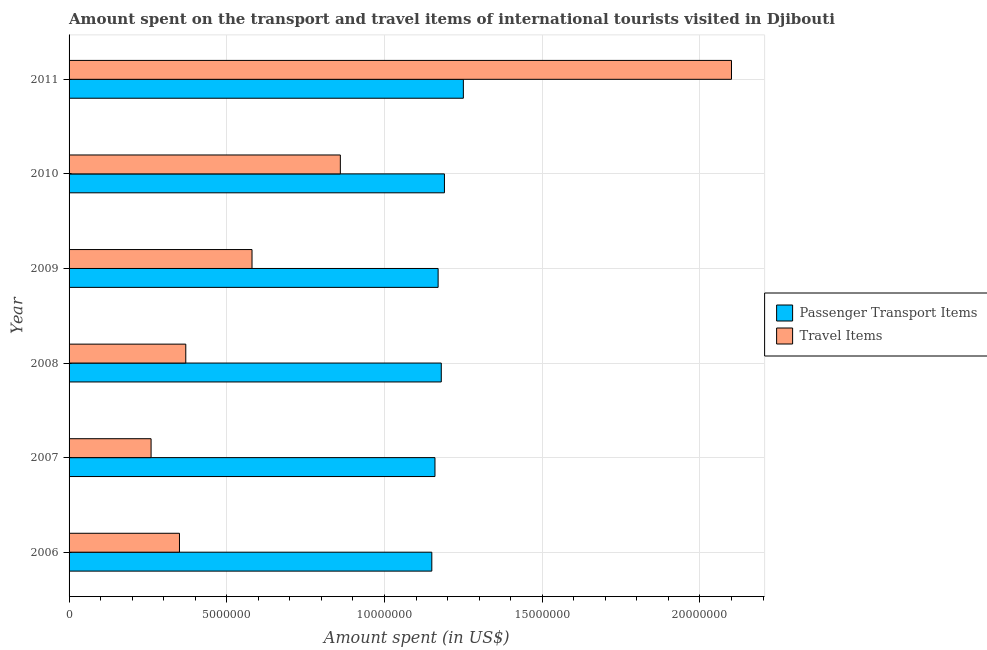Are the number of bars on each tick of the Y-axis equal?
Provide a succinct answer. Yes. How many bars are there on the 2nd tick from the bottom?
Your answer should be very brief. 2. What is the amount spent on passenger transport items in 2007?
Offer a very short reply. 1.16e+07. Across all years, what is the maximum amount spent on passenger transport items?
Keep it short and to the point. 1.25e+07. Across all years, what is the minimum amount spent on passenger transport items?
Provide a short and direct response. 1.15e+07. In which year was the amount spent in travel items minimum?
Your answer should be very brief. 2007. What is the total amount spent in travel items in the graph?
Your response must be concise. 4.52e+07. What is the difference between the amount spent in travel items in 2008 and that in 2009?
Provide a short and direct response. -2.10e+06. What is the difference between the amount spent in travel items in 2011 and the amount spent on passenger transport items in 2006?
Keep it short and to the point. 9.50e+06. What is the average amount spent in travel items per year?
Offer a terse response. 7.53e+06. In the year 2008, what is the difference between the amount spent on passenger transport items and amount spent in travel items?
Offer a terse response. 8.10e+06. In how many years, is the amount spent on passenger transport items greater than 18000000 US$?
Make the answer very short. 0. Is the amount spent in travel items in 2006 less than that in 2008?
Give a very brief answer. Yes. Is the difference between the amount spent on passenger transport items in 2007 and 2010 greater than the difference between the amount spent in travel items in 2007 and 2010?
Offer a very short reply. Yes. What is the difference between the highest and the lowest amount spent in travel items?
Give a very brief answer. 1.84e+07. Is the sum of the amount spent on passenger transport items in 2006 and 2007 greater than the maximum amount spent in travel items across all years?
Your response must be concise. Yes. What does the 2nd bar from the top in 2008 represents?
Offer a terse response. Passenger Transport Items. What does the 1st bar from the bottom in 2011 represents?
Provide a succinct answer. Passenger Transport Items. How many bars are there?
Your answer should be compact. 12. Are all the bars in the graph horizontal?
Offer a terse response. Yes. How many years are there in the graph?
Offer a very short reply. 6. What is the difference between two consecutive major ticks on the X-axis?
Ensure brevity in your answer.  5.00e+06. Does the graph contain any zero values?
Keep it short and to the point. No. Where does the legend appear in the graph?
Your response must be concise. Center right. What is the title of the graph?
Provide a short and direct response. Amount spent on the transport and travel items of international tourists visited in Djibouti. What is the label or title of the X-axis?
Provide a succinct answer. Amount spent (in US$). What is the Amount spent (in US$) of Passenger Transport Items in 2006?
Provide a succinct answer. 1.15e+07. What is the Amount spent (in US$) in Travel Items in 2006?
Your response must be concise. 3.50e+06. What is the Amount spent (in US$) of Passenger Transport Items in 2007?
Provide a succinct answer. 1.16e+07. What is the Amount spent (in US$) in Travel Items in 2007?
Give a very brief answer. 2.60e+06. What is the Amount spent (in US$) in Passenger Transport Items in 2008?
Ensure brevity in your answer.  1.18e+07. What is the Amount spent (in US$) of Travel Items in 2008?
Give a very brief answer. 3.70e+06. What is the Amount spent (in US$) of Passenger Transport Items in 2009?
Give a very brief answer. 1.17e+07. What is the Amount spent (in US$) of Travel Items in 2009?
Your answer should be very brief. 5.80e+06. What is the Amount spent (in US$) in Passenger Transport Items in 2010?
Your answer should be compact. 1.19e+07. What is the Amount spent (in US$) of Travel Items in 2010?
Ensure brevity in your answer.  8.60e+06. What is the Amount spent (in US$) in Passenger Transport Items in 2011?
Provide a succinct answer. 1.25e+07. What is the Amount spent (in US$) of Travel Items in 2011?
Your response must be concise. 2.10e+07. Across all years, what is the maximum Amount spent (in US$) in Passenger Transport Items?
Keep it short and to the point. 1.25e+07. Across all years, what is the maximum Amount spent (in US$) in Travel Items?
Your response must be concise. 2.10e+07. Across all years, what is the minimum Amount spent (in US$) in Passenger Transport Items?
Your answer should be very brief. 1.15e+07. Across all years, what is the minimum Amount spent (in US$) of Travel Items?
Your answer should be compact. 2.60e+06. What is the total Amount spent (in US$) in Passenger Transport Items in the graph?
Ensure brevity in your answer.  7.10e+07. What is the total Amount spent (in US$) in Travel Items in the graph?
Offer a very short reply. 4.52e+07. What is the difference between the Amount spent (in US$) of Passenger Transport Items in 2006 and that in 2007?
Keep it short and to the point. -1.00e+05. What is the difference between the Amount spent (in US$) of Travel Items in 2006 and that in 2008?
Keep it short and to the point. -2.00e+05. What is the difference between the Amount spent (in US$) of Passenger Transport Items in 2006 and that in 2009?
Provide a succinct answer. -2.00e+05. What is the difference between the Amount spent (in US$) of Travel Items in 2006 and that in 2009?
Provide a short and direct response. -2.30e+06. What is the difference between the Amount spent (in US$) of Passenger Transport Items in 2006 and that in 2010?
Your answer should be very brief. -4.00e+05. What is the difference between the Amount spent (in US$) of Travel Items in 2006 and that in 2010?
Ensure brevity in your answer.  -5.10e+06. What is the difference between the Amount spent (in US$) in Passenger Transport Items in 2006 and that in 2011?
Your answer should be very brief. -1.00e+06. What is the difference between the Amount spent (in US$) of Travel Items in 2006 and that in 2011?
Make the answer very short. -1.75e+07. What is the difference between the Amount spent (in US$) in Travel Items in 2007 and that in 2008?
Make the answer very short. -1.10e+06. What is the difference between the Amount spent (in US$) of Travel Items in 2007 and that in 2009?
Offer a very short reply. -3.20e+06. What is the difference between the Amount spent (in US$) in Travel Items in 2007 and that in 2010?
Your response must be concise. -6.00e+06. What is the difference between the Amount spent (in US$) of Passenger Transport Items in 2007 and that in 2011?
Offer a very short reply. -9.00e+05. What is the difference between the Amount spent (in US$) of Travel Items in 2007 and that in 2011?
Provide a succinct answer. -1.84e+07. What is the difference between the Amount spent (in US$) in Passenger Transport Items in 2008 and that in 2009?
Offer a very short reply. 1.00e+05. What is the difference between the Amount spent (in US$) in Travel Items in 2008 and that in 2009?
Give a very brief answer. -2.10e+06. What is the difference between the Amount spent (in US$) of Travel Items in 2008 and that in 2010?
Keep it short and to the point. -4.90e+06. What is the difference between the Amount spent (in US$) in Passenger Transport Items in 2008 and that in 2011?
Provide a short and direct response. -7.00e+05. What is the difference between the Amount spent (in US$) of Travel Items in 2008 and that in 2011?
Offer a terse response. -1.73e+07. What is the difference between the Amount spent (in US$) in Passenger Transport Items in 2009 and that in 2010?
Provide a succinct answer. -2.00e+05. What is the difference between the Amount spent (in US$) in Travel Items in 2009 and that in 2010?
Provide a succinct answer. -2.80e+06. What is the difference between the Amount spent (in US$) of Passenger Transport Items in 2009 and that in 2011?
Your response must be concise. -8.00e+05. What is the difference between the Amount spent (in US$) of Travel Items in 2009 and that in 2011?
Provide a succinct answer. -1.52e+07. What is the difference between the Amount spent (in US$) of Passenger Transport Items in 2010 and that in 2011?
Offer a terse response. -6.00e+05. What is the difference between the Amount spent (in US$) in Travel Items in 2010 and that in 2011?
Your answer should be very brief. -1.24e+07. What is the difference between the Amount spent (in US$) in Passenger Transport Items in 2006 and the Amount spent (in US$) in Travel Items in 2007?
Your response must be concise. 8.90e+06. What is the difference between the Amount spent (in US$) in Passenger Transport Items in 2006 and the Amount spent (in US$) in Travel Items in 2008?
Give a very brief answer. 7.80e+06. What is the difference between the Amount spent (in US$) of Passenger Transport Items in 2006 and the Amount spent (in US$) of Travel Items in 2009?
Give a very brief answer. 5.70e+06. What is the difference between the Amount spent (in US$) of Passenger Transport Items in 2006 and the Amount spent (in US$) of Travel Items in 2010?
Your answer should be compact. 2.90e+06. What is the difference between the Amount spent (in US$) of Passenger Transport Items in 2006 and the Amount spent (in US$) of Travel Items in 2011?
Your response must be concise. -9.50e+06. What is the difference between the Amount spent (in US$) of Passenger Transport Items in 2007 and the Amount spent (in US$) of Travel Items in 2008?
Give a very brief answer. 7.90e+06. What is the difference between the Amount spent (in US$) in Passenger Transport Items in 2007 and the Amount spent (in US$) in Travel Items in 2009?
Provide a short and direct response. 5.80e+06. What is the difference between the Amount spent (in US$) in Passenger Transport Items in 2007 and the Amount spent (in US$) in Travel Items in 2011?
Make the answer very short. -9.40e+06. What is the difference between the Amount spent (in US$) in Passenger Transport Items in 2008 and the Amount spent (in US$) in Travel Items in 2010?
Offer a terse response. 3.20e+06. What is the difference between the Amount spent (in US$) of Passenger Transport Items in 2008 and the Amount spent (in US$) of Travel Items in 2011?
Your answer should be very brief. -9.20e+06. What is the difference between the Amount spent (in US$) of Passenger Transport Items in 2009 and the Amount spent (in US$) of Travel Items in 2010?
Give a very brief answer. 3.10e+06. What is the difference between the Amount spent (in US$) of Passenger Transport Items in 2009 and the Amount spent (in US$) of Travel Items in 2011?
Your answer should be compact. -9.30e+06. What is the difference between the Amount spent (in US$) in Passenger Transport Items in 2010 and the Amount spent (in US$) in Travel Items in 2011?
Give a very brief answer. -9.10e+06. What is the average Amount spent (in US$) in Passenger Transport Items per year?
Ensure brevity in your answer.  1.18e+07. What is the average Amount spent (in US$) in Travel Items per year?
Ensure brevity in your answer.  7.53e+06. In the year 2007, what is the difference between the Amount spent (in US$) of Passenger Transport Items and Amount spent (in US$) of Travel Items?
Offer a very short reply. 9.00e+06. In the year 2008, what is the difference between the Amount spent (in US$) in Passenger Transport Items and Amount spent (in US$) in Travel Items?
Give a very brief answer. 8.10e+06. In the year 2009, what is the difference between the Amount spent (in US$) in Passenger Transport Items and Amount spent (in US$) in Travel Items?
Offer a very short reply. 5.90e+06. In the year 2010, what is the difference between the Amount spent (in US$) of Passenger Transport Items and Amount spent (in US$) of Travel Items?
Your answer should be compact. 3.30e+06. In the year 2011, what is the difference between the Amount spent (in US$) in Passenger Transport Items and Amount spent (in US$) in Travel Items?
Give a very brief answer. -8.50e+06. What is the ratio of the Amount spent (in US$) in Travel Items in 2006 to that in 2007?
Your answer should be compact. 1.35. What is the ratio of the Amount spent (in US$) in Passenger Transport Items in 2006 to that in 2008?
Ensure brevity in your answer.  0.97. What is the ratio of the Amount spent (in US$) in Travel Items in 2006 to that in 2008?
Offer a very short reply. 0.95. What is the ratio of the Amount spent (in US$) of Passenger Transport Items in 2006 to that in 2009?
Ensure brevity in your answer.  0.98. What is the ratio of the Amount spent (in US$) in Travel Items in 2006 to that in 2009?
Provide a succinct answer. 0.6. What is the ratio of the Amount spent (in US$) in Passenger Transport Items in 2006 to that in 2010?
Keep it short and to the point. 0.97. What is the ratio of the Amount spent (in US$) of Travel Items in 2006 to that in 2010?
Your answer should be compact. 0.41. What is the ratio of the Amount spent (in US$) in Passenger Transport Items in 2006 to that in 2011?
Ensure brevity in your answer.  0.92. What is the ratio of the Amount spent (in US$) of Travel Items in 2006 to that in 2011?
Keep it short and to the point. 0.17. What is the ratio of the Amount spent (in US$) of Passenger Transport Items in 2007 to that in 2008?
Give a very brief answer. 0.98. What is the ratio of the Amount spent (in US$) in Travel Items in 2007 to that in 2008?
Make the answer very short. 0.7. What is the ratio of the Amount spent (in US$) in Passenger Transport Items in 2007 to that in 2009?
Your answer should be very brief. 0.99. What is the ratio of the Amount spent (in US$) of Travel Items in 2007 to that in 2009?
Make the answer very short. 0.45. What is the ratio of the Amount spent (in US$) of Passenger Transport Items in 2007 to that in 2010?
Ensure brevity in your answer.  0.97. What is the ratio of the Amount spent (in US$) in Travel Items in 2007 to that in 2010?
Provide a succinct answer. 0.3. What is the ratio of the Amount spent (in US$) in Passenger Transport Items in 2007 to that in 2011?
Make the answer very short. 0.93. What is the ratio of the Amount spent (in US$) in Travel Items in 2007 to that in 2011?
Provide a short and direct response. 0.12. What is the ratio of the Amount spent (in US$) of Passenger Transport Items in 2008 to that in 2009?
Provide a succinct answer. 1.01. What is the ratio of the Amount spent (in US$) of Travel Items in 2008 to that in 2009?
Offer a terse response. 0.64. What is the ratio of the Amount spent (in US$) of Passenger Transport Items in 2008 to that in 2010?
Give a very brief answer. 0.99. What is the ratio of the Amount spent (in US$) of Travel Items in 2008 to that in 2010?
Give a very brief answer. 0.43. What is the ratio of the Amount spent (in US$) of Passenger Transport Items in 2008 to that in 2011?
Offer a very short reply. 0.94. What is the ratio of the Amount spent (in US$) of Travel Items in 2008 to that in 2011?
Give a very brief answer. 0.18. What is the ratio of the Amount spent (in US$) in Passenger Transport Items in 2009 to that in 2010?
Offer a very short reply. 0.98. What is the ratio of the Amount spent (in US$) in Travel Items in 2009 to that in 2010?
Keep it short and to the point. 0.67. What is the ratio of the Amount spent (in US$) in Passenger Transport Items in 2009 to that in 2011?
Give a very brief answer. 0.94. What is the ratio of the Amount spent (in US$) of Travel Items in 2009 to that in 2011?
Keep it short and to the point. 0.28. What is the ratio of the Amount spent (in US$) of Passenger Transport Items in 2010 to that in 2011?
Provide a short and direct response. 0.95. What is the ratio of the Amount spent (in US$) in Travel Items in 2010 to that in 2011?
Keep it short and to the point. 0.41. What is the difference between the highest and the second highest Amount spent (in US$) in Passenger Transport Items?
Provide a short and direct response. 6.00e+05. What is the difference between the highest and the second highest Amount spent (in US$) of Travel Items?
Keep it short and to the point. 1.24e+07. What is the difference between the highest and the lowest Amount spent (in US$) in Passenger Transport Items?
Provide a short and direct response. 1.00e+06. What is the difference between the highest and the lowest Amount spent (in US$) in Travel Items?
Offer a terse response. 1.84e+07. 